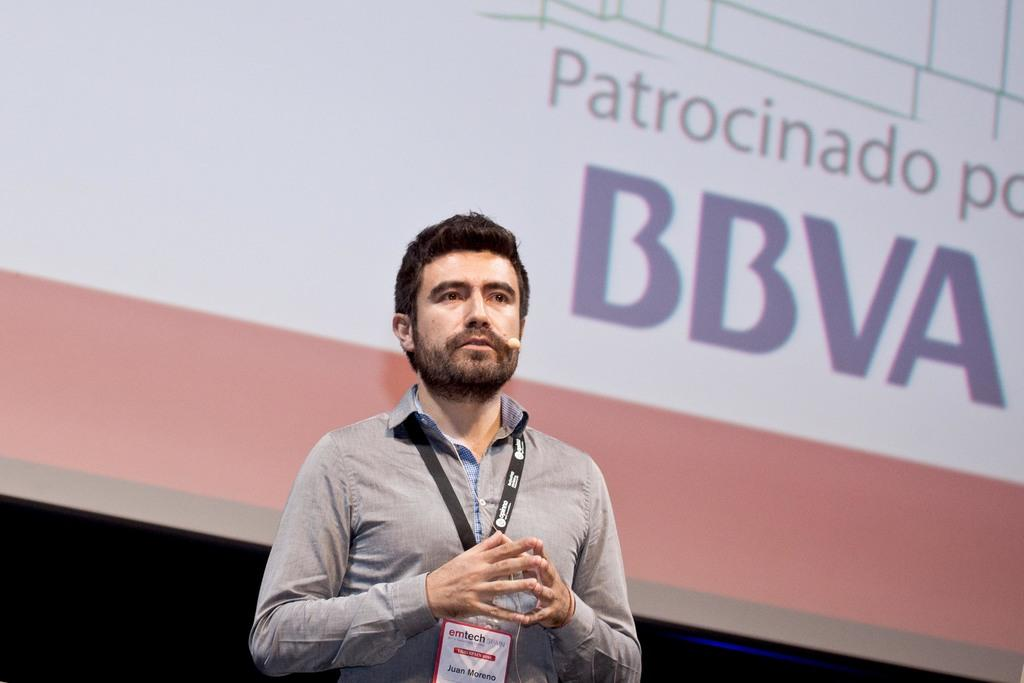<image>
Describe the image concisely. Juan Moreno giving a presentation for emtech spain 